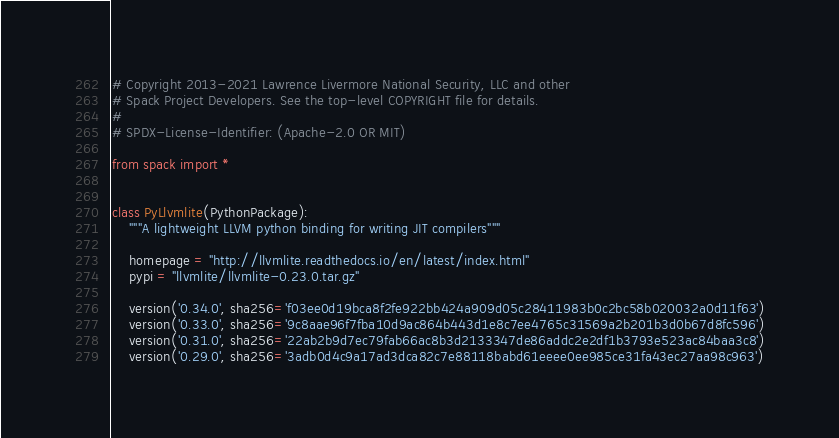<code> <loc_0><loc_0><loc_500><loc_500><_Python_># Copyright 2013-2021 Lawrence Livermore National Security, LLC and other
# Spack Project Developers. See the top-level COPYRIGHT file for details.
#
# SPDX-License-Identifier: (Apache-2.0 OR MIT)

from spack import *


class PyLlvmlite(PythonPackage):
    """A lightweight LLVM python binding for writing JIT compilers"""

    homepage = "http://llvmlite.readthedocs.io/en/latest/index.html"
    pypi = "llvmlite/llvmlite-0.23.0.tar.gz"

    version('0.34.0', sha256='f03ee0d19bca8f2fe922bb424a909d05c28411983b0c2bc58b020032a0d11f63')
    version('0.33.0', sha256='9c8aae96f7fba10d9ac864b443d1e8c7ee4765c31569a2b201b3d0b67d8fc596')
    version('0.31.0', sha256='22ab2b9d7ec79fab66ac8b3d2133347de86addc2e2df1b3793e523ac84baa3c8')
    version('0.29.0', sha256='3adb0d4c9a17ad3dca82c7e88118babd61eeee0ee985ce31fa43ec27aa98c963')</code> 